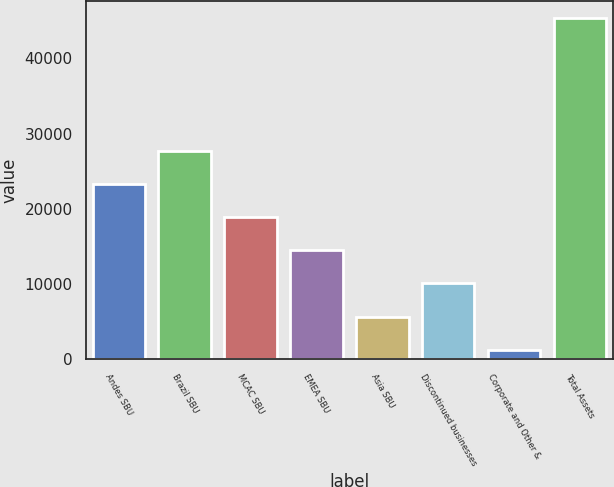Convert chart to OTSL. <chart><loc_0><loc_0><loc_500><loc_500><bar_chart><fcel>Andes SBU<fcel>Brazil SBU<fcel>MCAC SBU<fcel>EMEA SBU<fcel>Asia SBU<fcel>Discontinued businesses<fcel>Corporate and Other &<fcel>Total Assets<nl><fcel>23300.5<fcel>27709.6<fcel>18891.4<fcel>14482.3<fcel>5664.1<fcel>10073.2<fcel>1255<fcel>45346<nl></chart> 